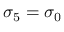Convert formula to latex. <formula><loc_0><loc_0><loc_500><loc_500>\sigma _ { 5 } = \sigma _ { 0 }</formula> 